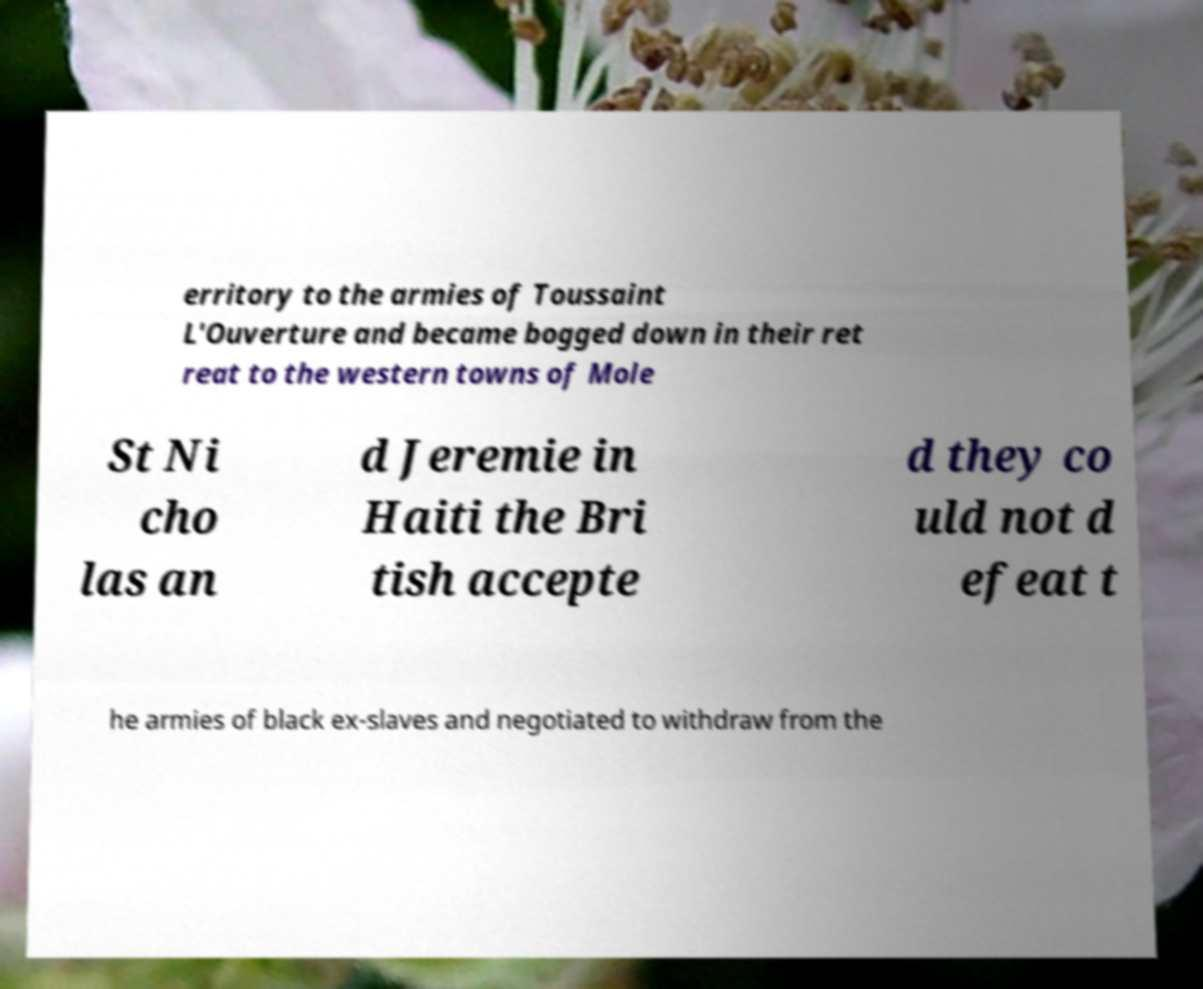Can you accurately transcribe the text from the provided image for me? erritory to the armies of Toussaint L'Ouverture and became bogged down in their ret reat to the western towns of Mole St Ni cho las an d Jeremie in Haiti the Bri tish accepte d they co uld not d efeat t he armies of black ex-slaves and negotiated to withdraw from the 